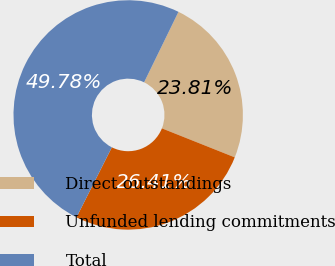<chart> <loc_0><loc_0><loc_500><loc_500><pie_chart><fcel>Direct outstandings<fcel>Unfunded lending commitments<fcel>Total<nl><fcel>23.81%<fcel>26.41%<fcel>49.78%<nl></chart> 